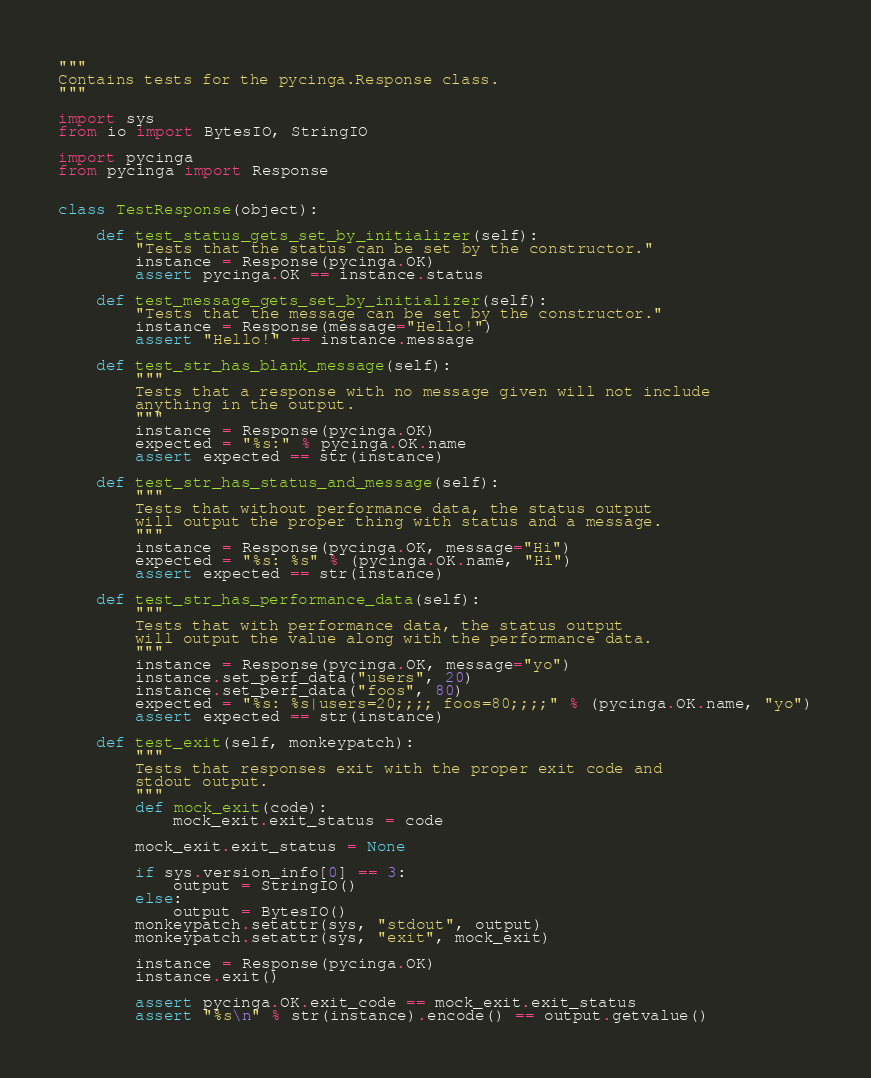<code> <loc_0><loc_0><loc_500><loc_500><_Python_>"""
Contains tests for the pycinga.Response class.
"""

import sys
from io import BytesIO, StringIO

import pycinga
from pycinga import Response


class TestResponse(object):

    def test_status_gets_set_by_initializer(self):
        "Tests that the status can be set by the constructor."
        instance = Response(pycinga.OK)
        assert pycinga.OK == instance.status

    def test_message_gets_set_by_initializer(self):
        "Tests that the message can be set by the constructor."
        instance = Response(message="Hello!")
        assert "Hello!" == instance.message

    def test_str_has_blank_message(self):
        """
        Tests that a response with no message given will not include
        anything in the output.
        """
        instance = Response(pycinga.OK)
        expected = "%s:" % pycinga.OK.name
        assert expected == str(instance)

    def test_str_has_status_and_message(self):
        """
        Tests that without performance data, the status output
        will output the proper thing with status and a message.
        """
        instance = Response(pycinga.OK, message="Hi")
        expected = "%s: %s" % (pycinga.OK.name, "Hi")
        assert expected == str(instance)

    def test_str_has_performance_data(self):
        """
        Tests that with performance data, the status output
        will output the value along with the performance data.
        """
        instance = Response(pycinga.OK, message="yo")
        instance.set_perf_data("users", 20)
        instance.set_perf_data("foos", 80)
        expected = "%s: %s|users=20;;;; foos=80;;;;" % (pycinga.OK.name, "yo")
        assert expected == str(instance)

    def test_exit(self, monkeypatch):
        """
        Tests that responses exit with the proper exit code and
        stdout output.
        """
        def mock_exit(code):
            mock_exit.exit_status = code

        mock_exit.exit_status = None

        if sys.version_info[0] == 3:
            output = StringIO()
        else:
            output = BytesIO()
        monkeypatch.setattr(sys, "stdout", output)
        monkeypatch.setattr(sys, "exit", mock_exit)

        instance = Response(pycinga.OK)
        instance.exit()

        assert pycinga.OK.exit_code == mock_exit.exit_status
        assert "%s\n" % str(instance).encode() == output.getvalue()
</code> 